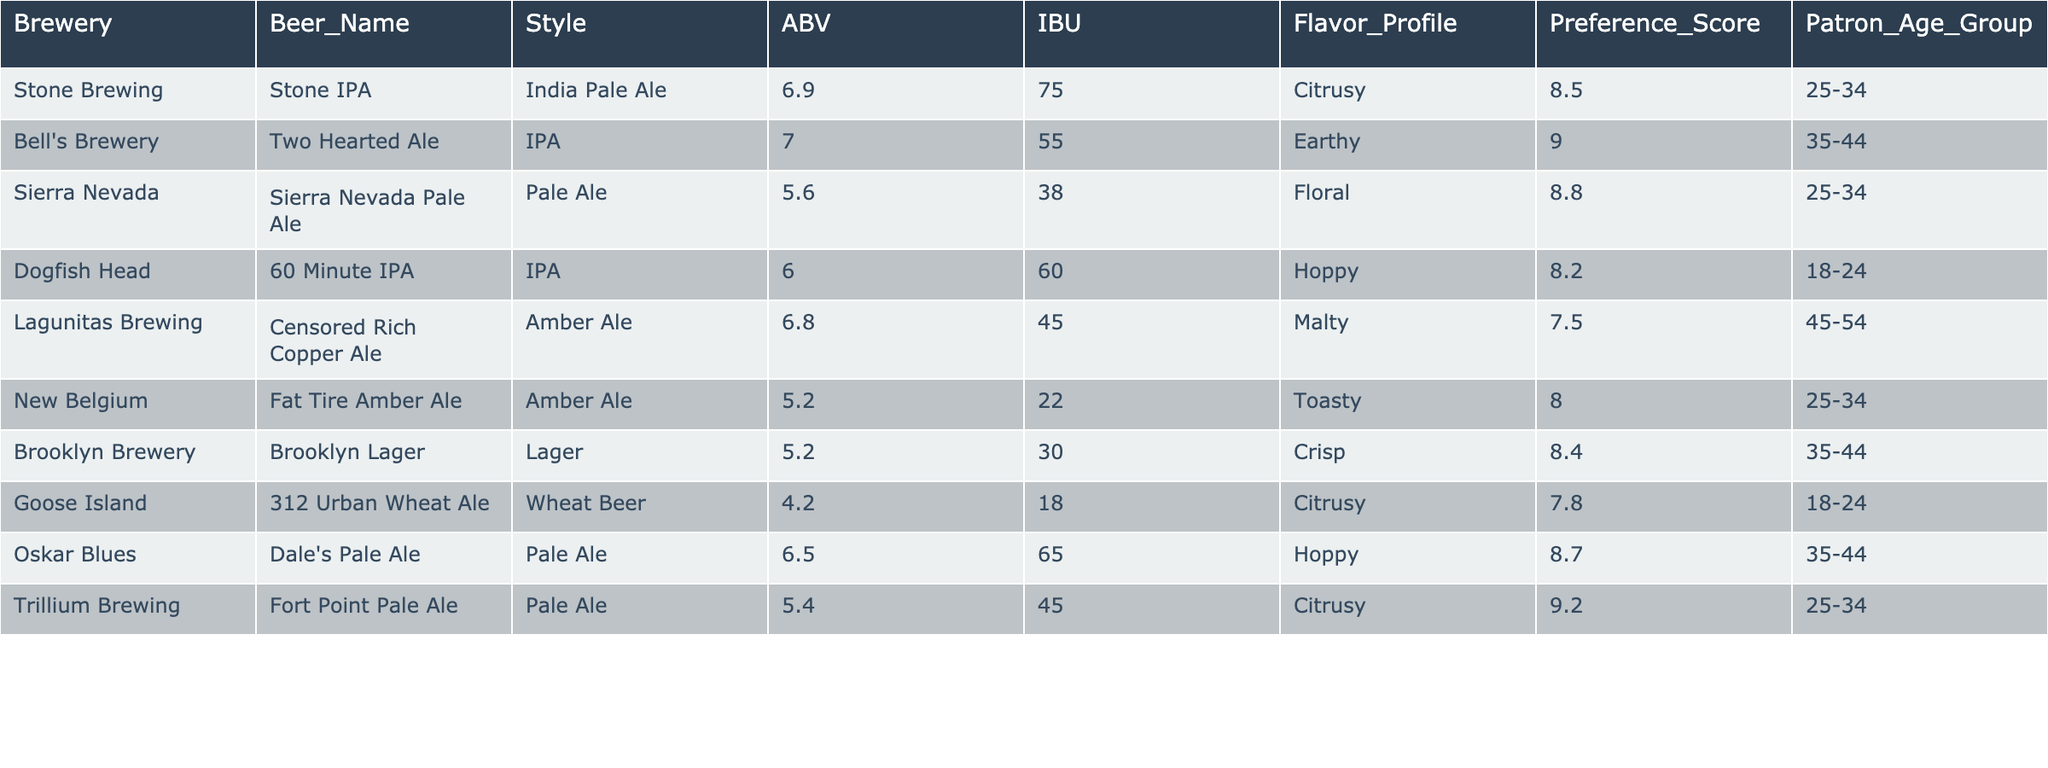What is the highest Preference Score among the craft beers? The Preference Scores show the values for each beer. Scanning through the table, the highest score of 9.2 corresponds to Trillium Brewing's Fort Point Pale Ale.
Answer: 9.2 Which brewery produces the beer with the lowest ABV? From the table, the ABV values can be observed. The lowest ABV is 4.2, which is produced by Goose Island for their 312 Urban Wheat Ale.
Answer: 4.2 Are there any beers with a Preference Score above 9.0? By examining the Preference Scores, we see that Two Hearted Ale (9.0) and Fort Point Pale Ale (9.2) both have scores equal to or above 9.0. Therefore, the answer is yes.
Answer: Yes What is the average ABV of the beers preferred by patrons aged 25-34? First, identify the beers preferred by the 25-34 age group: Stone IPA, Sierra Nevada Pale Ale, Fat Tire Amber Ale, and Fort Point Pale Ale. Their ABVs are 6.9, 5.6, 5.2, and 5.4 respectively. We sum these as (6.9 + 5.6 + 5.2 + 5.4) = 23.1. There are 4 beers, so the average ABV is 23.1 / 4 = 5.775.
Answer: 5.775 Which flavor profile is most commonly associated with beers preferred by patrons aged 35-44? The beers preferred by 35-44 patrons are Two Hearted Ale, Brooklyn Lager, and Dale's Pale Ale. The flavor profiles for these beers are earthy, crisp, and hoppy. There is no single flavor profile repeated, so the most common profile cannot be determined from this subset.
Answer: None What is the IBU difference between the beer with the highest Preference Score and the beer with the lowest Preference Score? The beer with the highest score is Fort Point Pale Ale (9.2), which has an IBU of 45. The lowest score is for Censored Rich Copper Ale (7.5) with an IBU of 45. The IBU difference is 45 - 45 = 0.
Answer: 0 Which age group favored the most beers with a Preference Score of 8.5 or higher? Looking at the Preference Scores, Stone IPA (8.5), Two Hearted Ale (9.0), Sierra Nevada Pale Ale (8.8), Oskar Blues Dale's Pale Ale (8.7), and Fort Point Pale Ale (9.2) have scores 8.5 or higher. The age groups for these beers are 25-34 (2 beers), 35-44 (3 beers), and 18-24 (1 beer). The age group 35-44 favored the most beers.
Answer: 35-44 